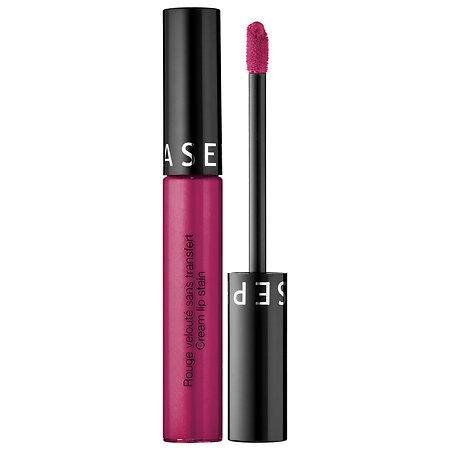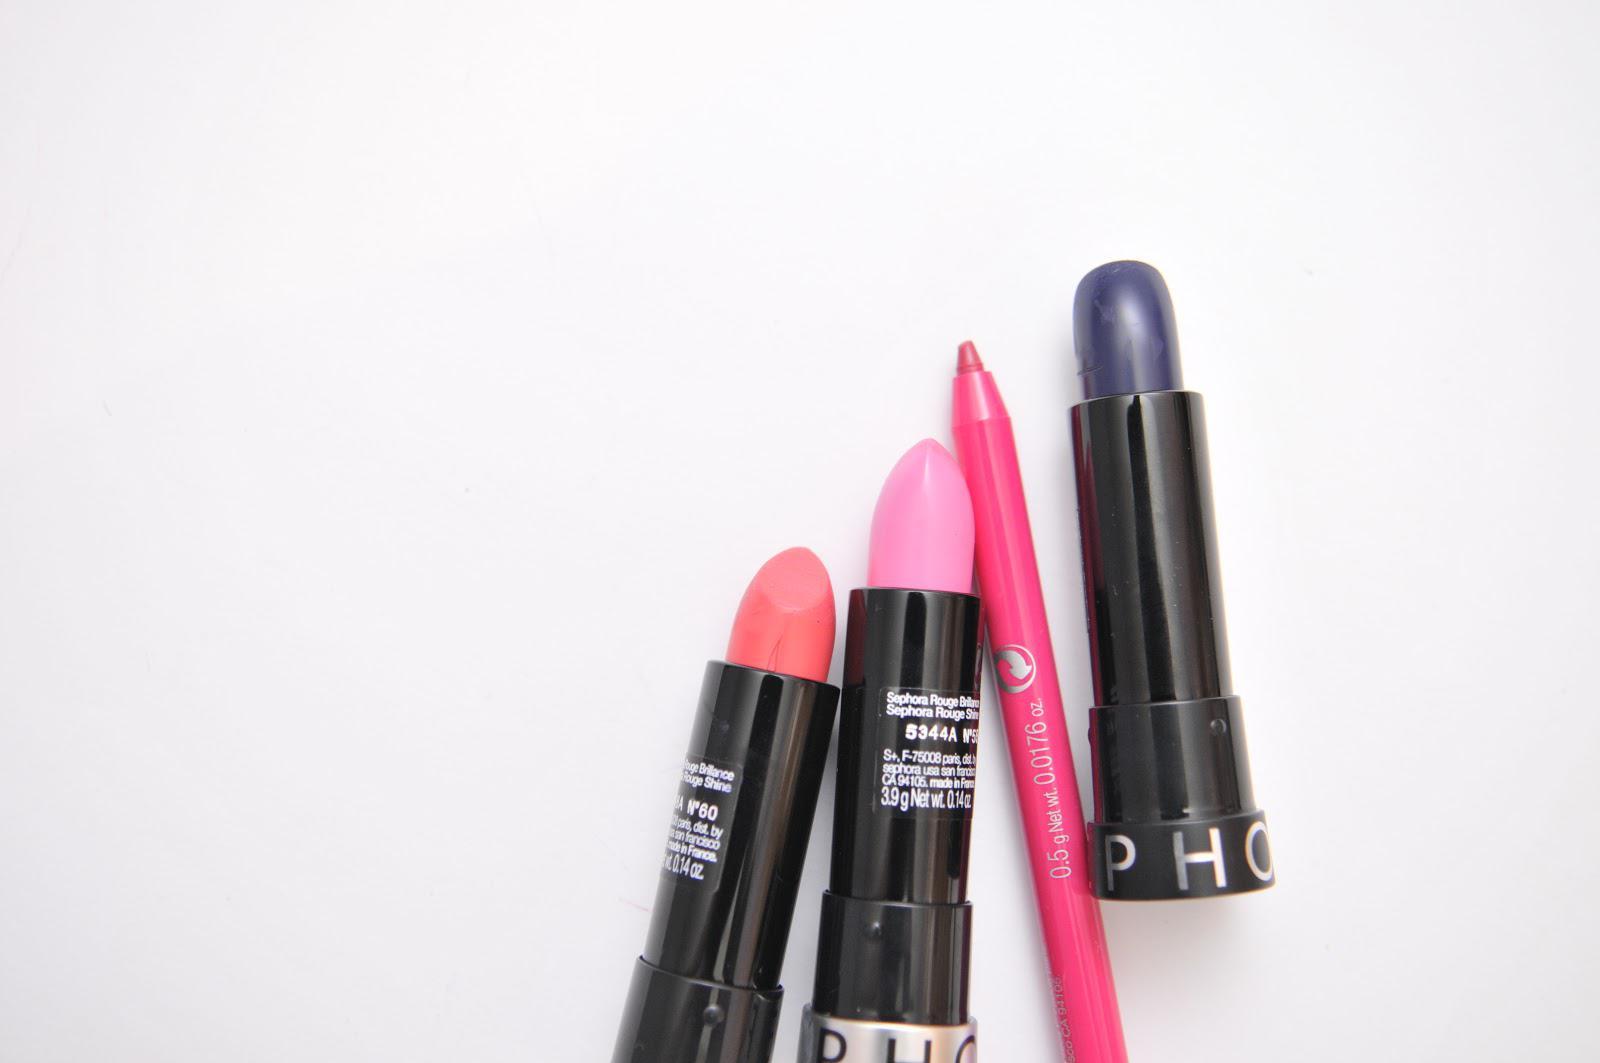The first image is the image on the left, the second image is the image on the right. For the images displayed, is the sentence "Each image shows just one standard lipstick next to only its lid." factually correct? Answer yes or no. No. The first image is the image on the left, the second image is the image on the right. For the images shown, is this caption "One lipstick has a silver casing and the other has a black casing." true? Answer yes or no. No. 